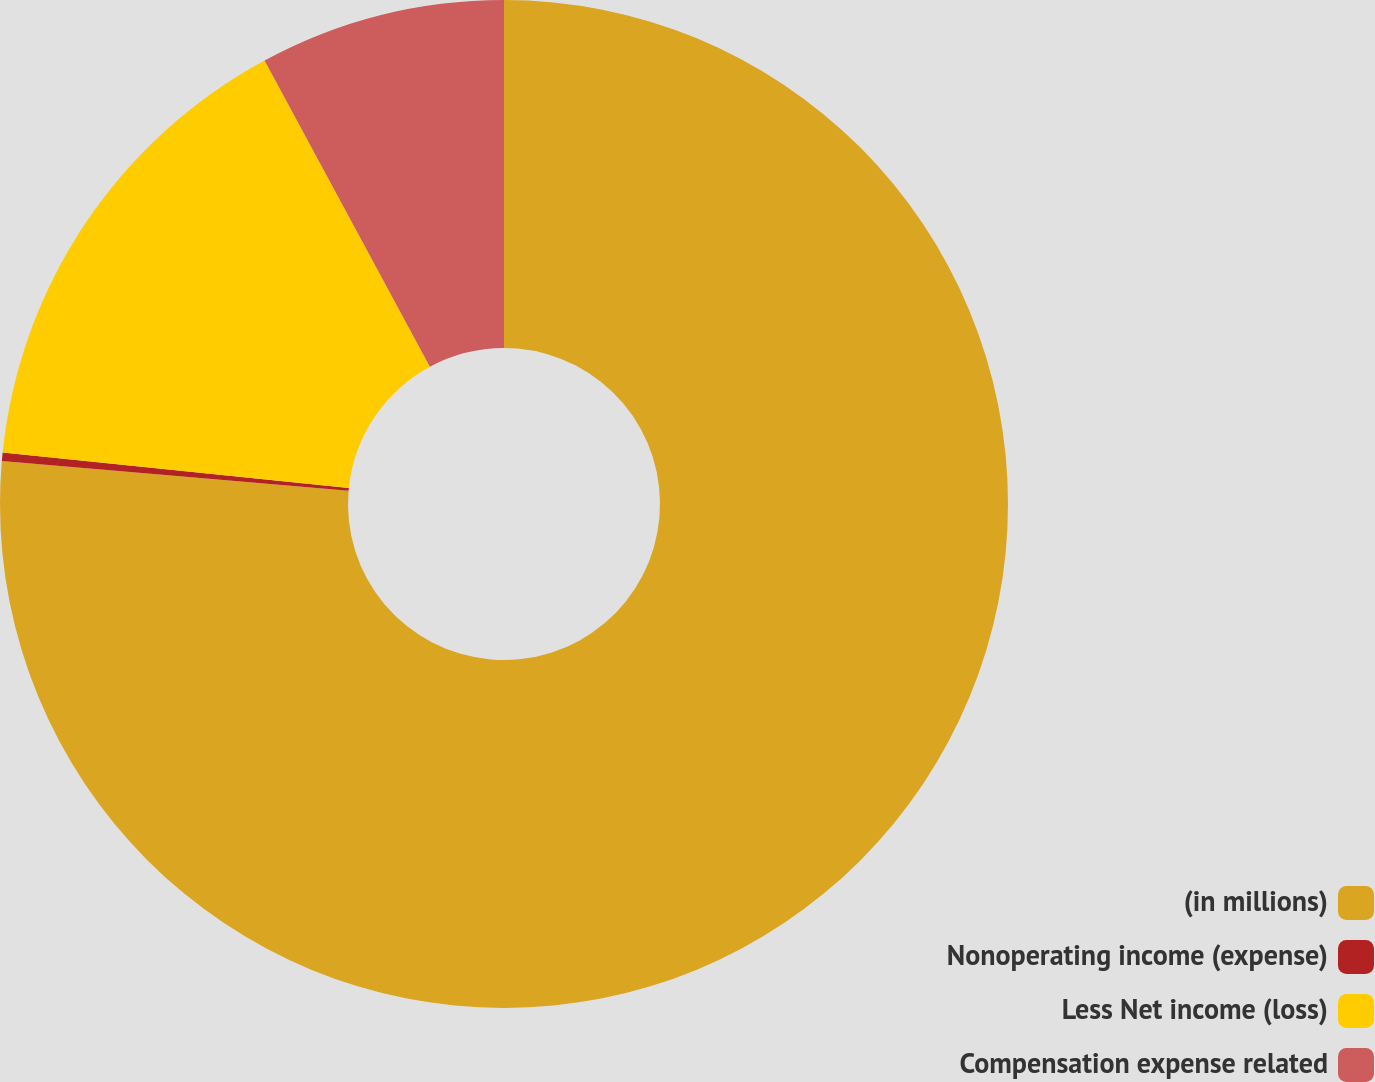Convert chart to OTSL. <chart><loc_0><loc_0><loc_500><loc_500><pie_chart><fcel>(in millions)<fcel>Nonoperating income (expense)<fcel>Less Net income (loss)<fcel>Compensation expense related<nl><fcel>76.37%<fcel>0.27%<fcel>15.49%<fcel>7.88%<nl></chart> 